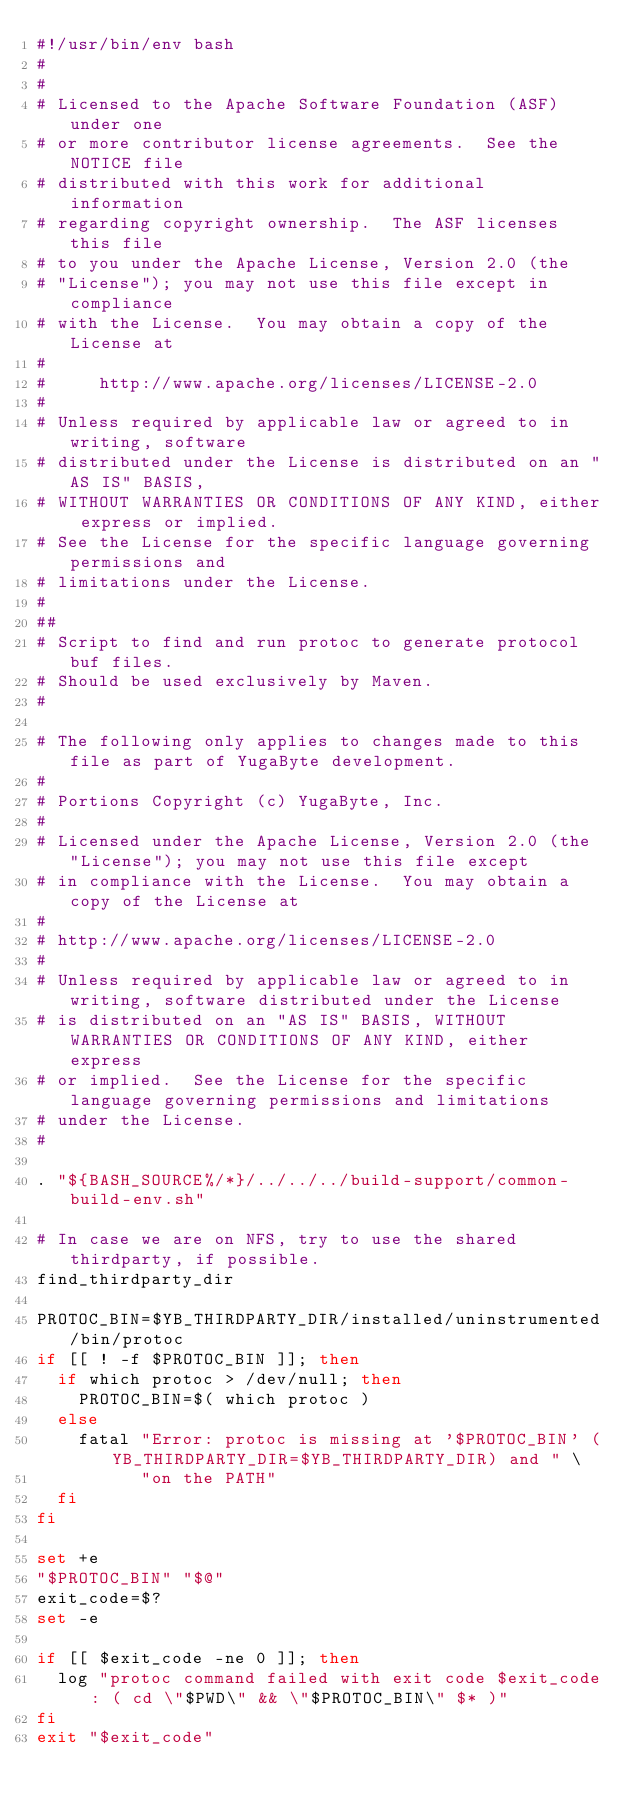<code> <loc_0><loc_0><loc_500><loc_500><_Bash_>#!/usr/bin/env bash
#
#
# Licensed to the Apache Software Foundation (ASF) under one
# or more contributor license agreements.  See the NOTICE file
# distributed with this work for additional information
# regarding copyright ownership.  The ASF licenses this file
# to you under the Apache License, Version 2.0 (the
# "License"); you may not use this file except in compliance
# with the License.  You may obtain a copy of the License at
#
#     http://www.apache.org/licenses/LICENSE-2.0
#
# Unless required by applicable law or agreed to in writing, software
# distributed under the License is distributed on an "AS IS" BASIS,
# WITHOUT WARRANTIES OR CONDITIONS OF ANY KIND, either express or implied.
# See the License for the specific language governing permissions and
# limitations under the License.
#
##
# Script to find and run protoc to generate protocol buf files.
# Should be used exclusively by Maven.
#

# The following only applies to changes made to this file as part of YugaByte development.
#
# Portions Copyright (c) YugaByte, Inc.
#
# Licensed under the Apache License, Version 2.0 (the "License"); you may not use this file except
# in compliance with the License.  You may obtain a copy of the License at
#
# http://www.apache.org/licenses/LICENSE-2.0
#
# Unless required by applicable law or agreed to in writing, software distributed under the License
# is distributed on an "AS IS" BASIS, WITHOUT WARRANTIES OR CONDITIONS OF ANY KIND, either express
# or implied.  See the License for the specific language governing permissions and limitations
# under the License.
#

. "${BASH_SOURCE%/*}/../../../build-support/common-build-env.sh"

# In case we are on NFS, try to use the shared thirdparty, if possible.
find_thirdparty_dir

PROTOC_BIN=$YB_THIRDPARTY_DIR/installed/uninstrumented/bin/protoc
if [[ ! -f $PROTOC_BIN ]]; then
  if which protoc > /dev/null; then
    PROTOC_BIN=$( which protoc )
  else
    fatal "Error: protoc is missing at '$PROTOC_BIN' (YB_THIRDPARTY_DIR=$YB_THIRDPARTY_DIR) and " \
          "on the PATH"
  fi
fi

set +e
"$PROTOC_BIN" "$@"
exit_code=$?
set -e

if [[ $exit_code -ne 0 ]]; then
  log "protoc command failed with exit code $exit_code: ( cd \"$PWD\" && \"$PROTOC_BIN\" $* )"
fi
exit "$exit_code"
</code> 